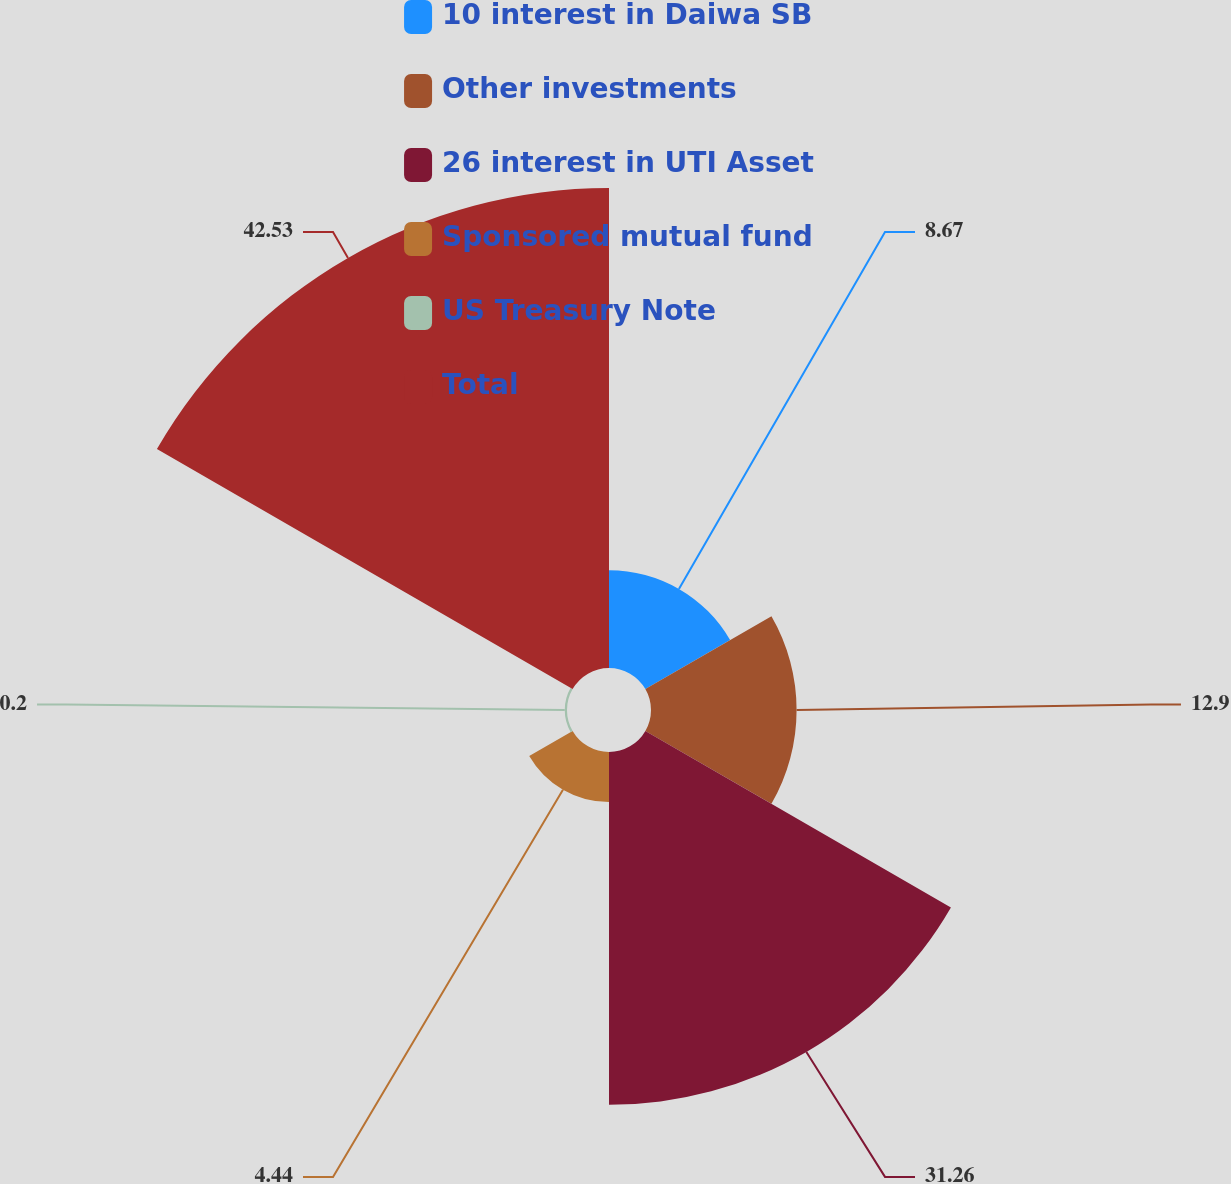Convert chart to OTSL. <chart><loc_0><loc_0><loc_500><loc_500><pie_chart><fcel>10 interest in Daiwa SB<fcel>Other investments<fcel>26 interest in UTI Asset<fcel>Sponsored mutual fund<fcel>US Treasury Note<fcel>Total<nl><fcel>8.67%<fcel>12.9%<fcel>31.26%<fcel>4.44%<fcel>0.2%<fcel>42.53%<nl></chart> 